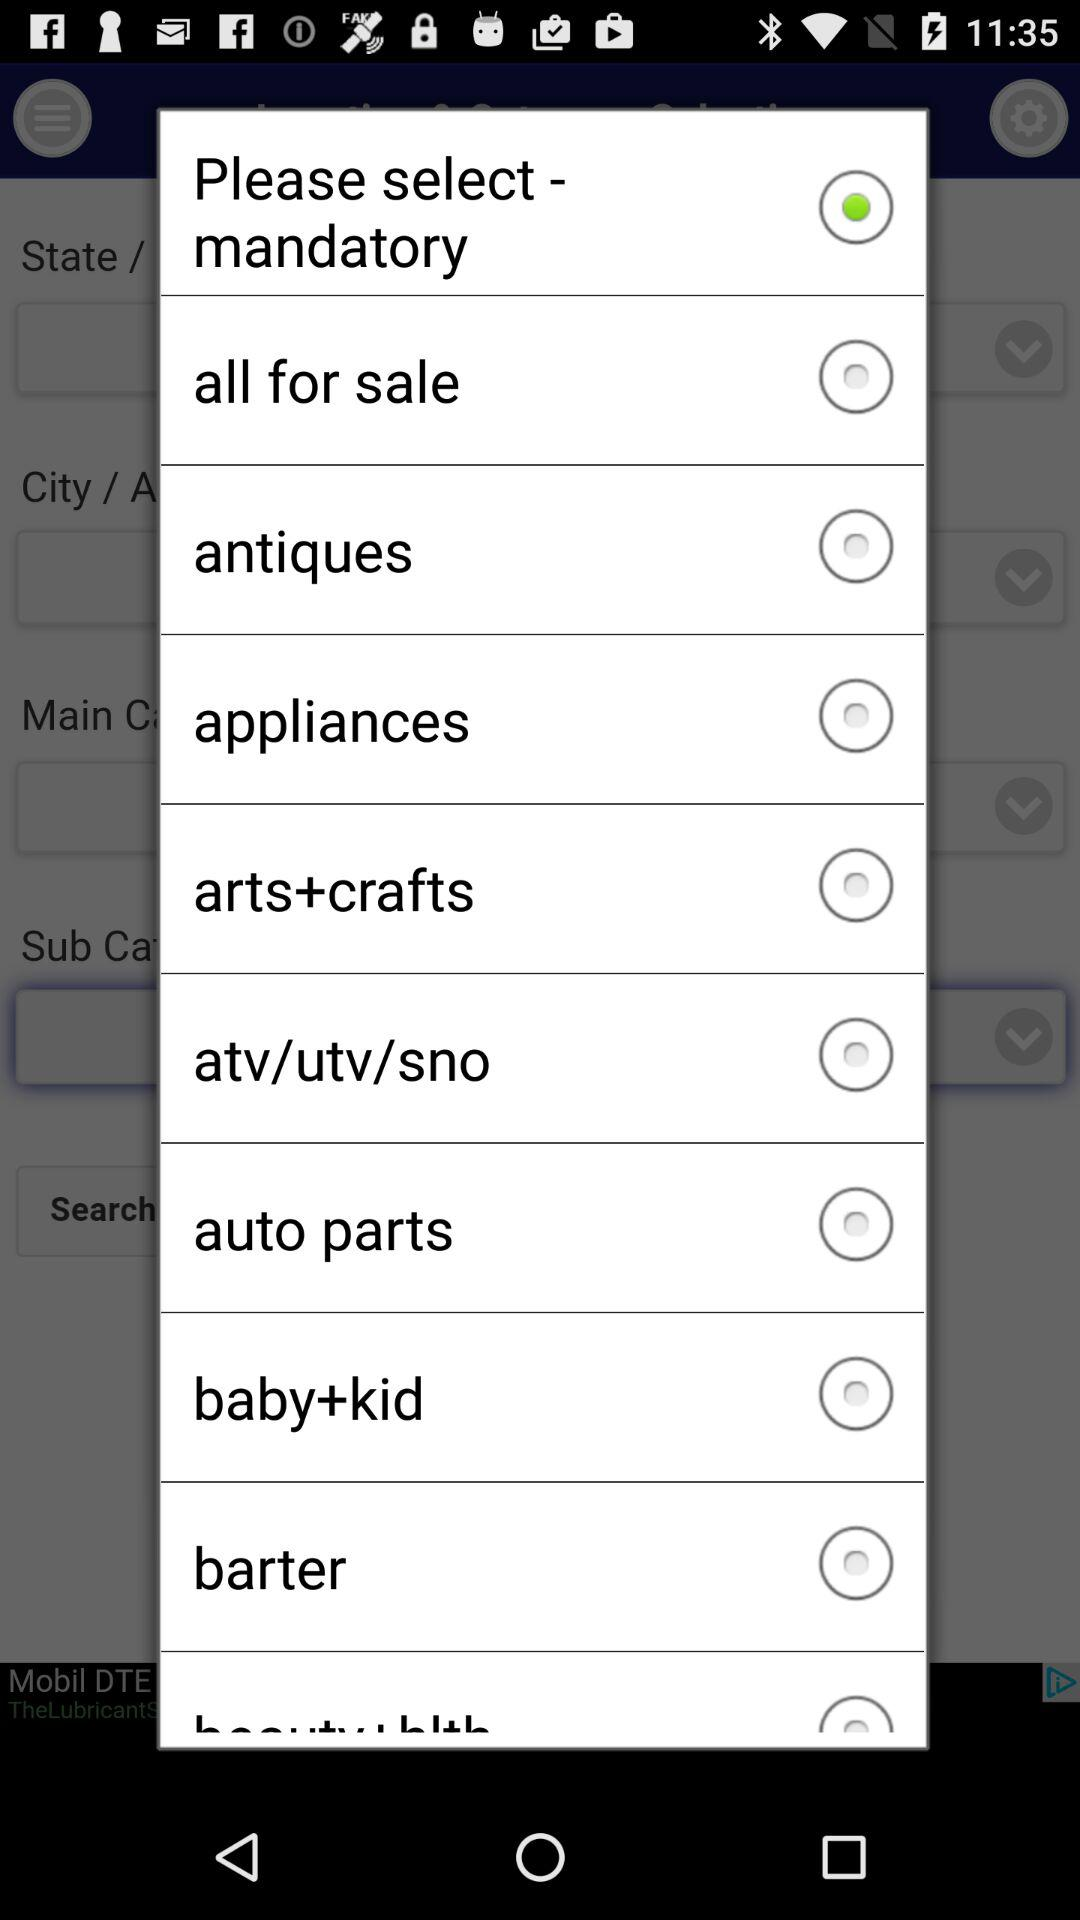List of mandatory things to choose from? The list of mandatory things is "all for sale", "antiques", "appliances", "arts+crafts", "atv/utv/sno", "auto parts", "baby+kid" and "barter". 